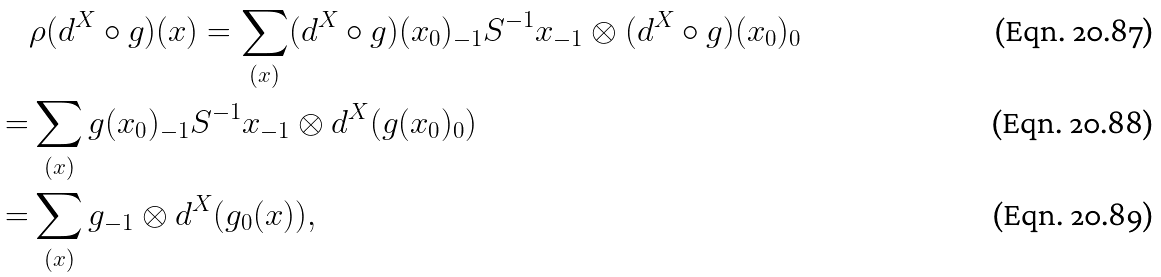Convert formula to latex. <formula><loc_0><loc_0><loc_500><loc_500>& \rho ( d ^ { X } \circ g ) ( x ) = \sum _ { ( x ) } ( d ^ { X } \circ g ) ( x _ { 0 } ) _ { - 1 } S ^ { - 1 } x _ { - 1 } \otimes ( d ^ { X } \circ g ) ( x _ { 0 } ) _ { 0 } \\ = & \sum _ { ( x ) } g ( x _ { 0 } ) _ { - 1 } S ^ { - 1 } x _ { - 1 } \otimes d ^ { X } ( g ( x _ { 0 } ) _ { 0 } ) \\ = & \sum _ { ( x ) } g _ { - 1 } \otimes d ^ { X } ( g _ { 0 } ( x ) ) ,</formula> 